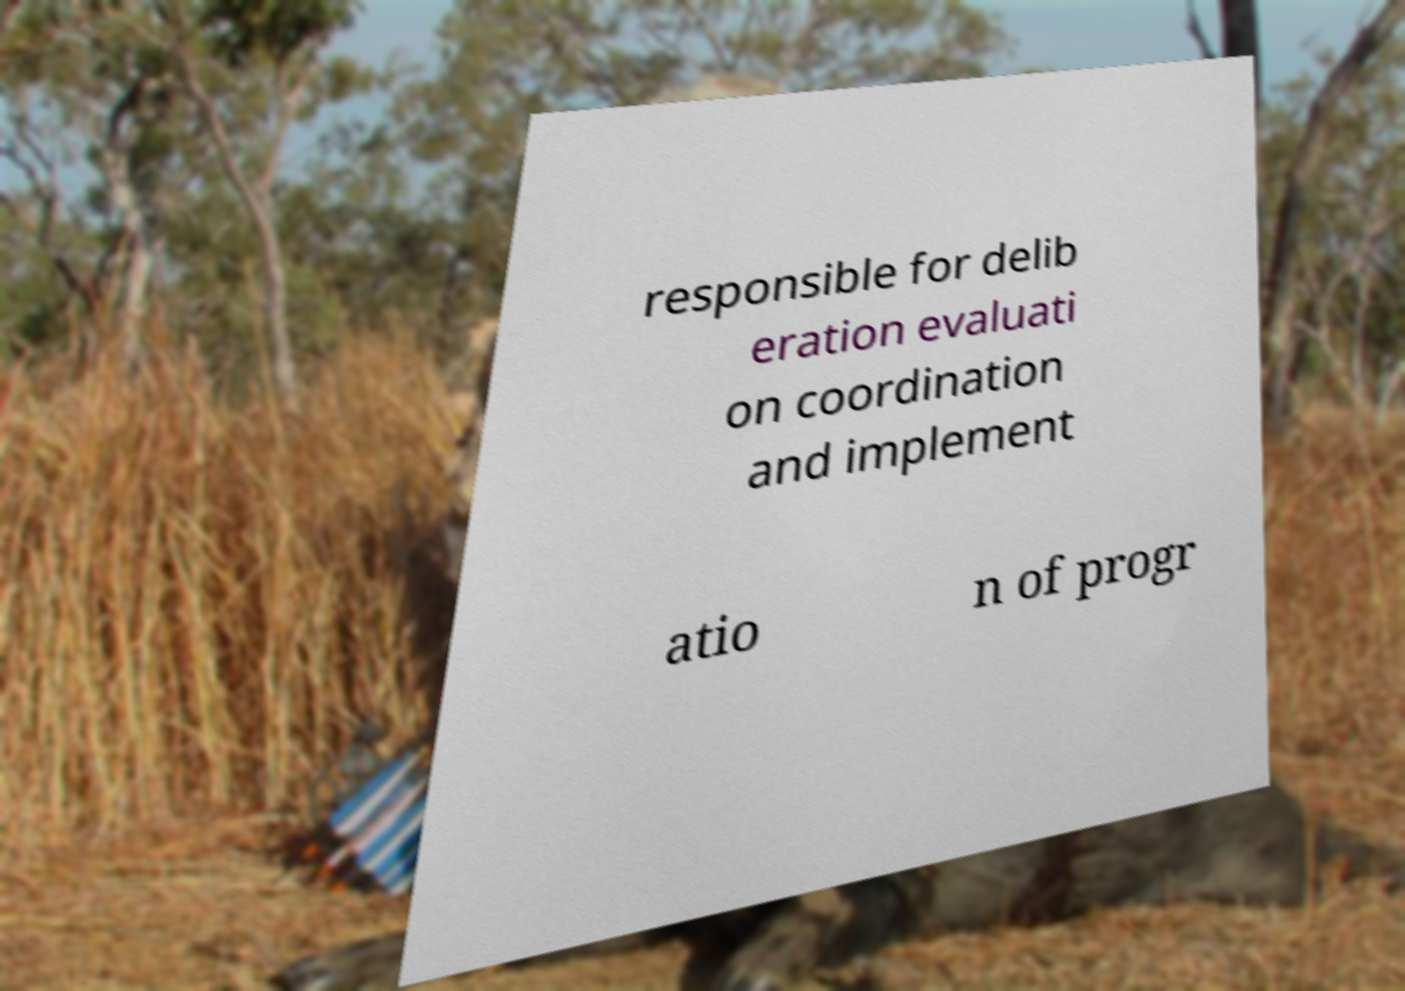For documentation purposes, I need the text within this image transcribed. Could you provide that? responsible for delib eration evaluati on coordination and implement atio n of progr 